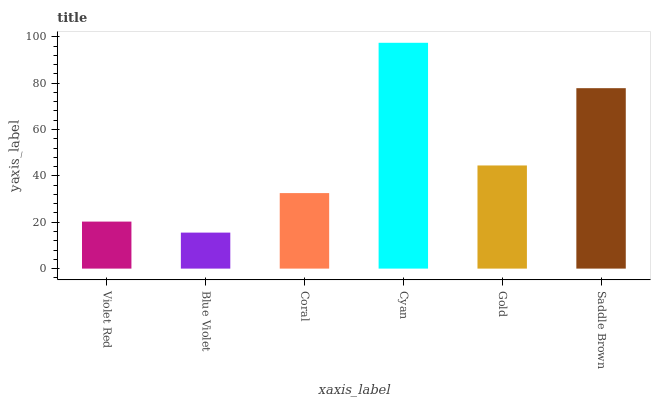Is Blue Violet the minimum?
Answer yes or no. Yes. Is Cyan the maximum?
Answer yes or no. Yes. Is Coral the minimum?
Answer yes or no. No. Is Coral the maximum?
Answer yes or no. No. Is Coral greater than Blue Violet?
Answer yes or no. Yes. Is Blue Violet less than Coral?
Answer yes or no. Yes. Is Blue Violet greater than Coral?
Answer yes or no. No. Is Coral less than Blue Violet?
Answer yes or no. No. Is Gold the high median?
Answer yes or no. Yes. Is Coral the low median?
Answer yes or no. Yes. Is Saddle Brown the high median?
Answer yes or no. No. Is Violet Red the low median?
Answer yes or no. No. 